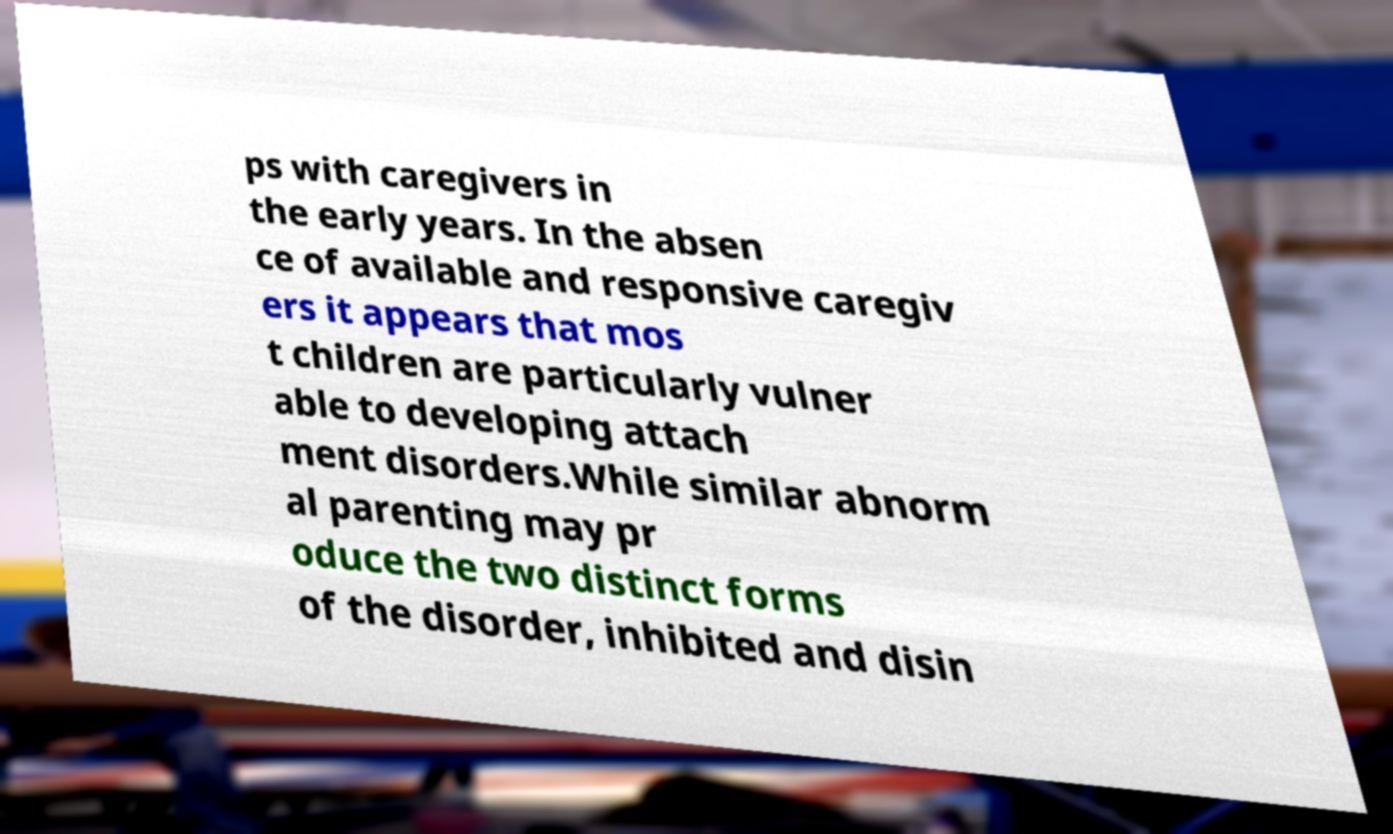Can you accurately transcribe the text from the provided image for me? ps with caregivers in the early years. In the absen ce of available and responsive caregiv ers it appears that mos t children are particularly vulner able to developing attach ment disorders.While similar abnorm al parenting may pr oduce the two distinct forms of the disorder, inhibited and disin 